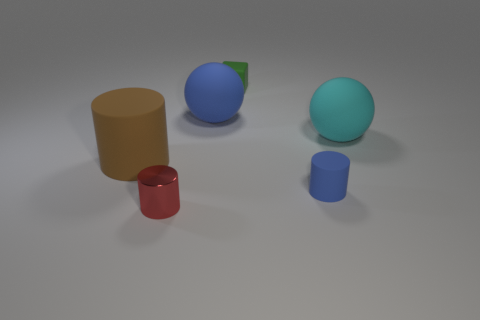Are there any other things that have the same material as the red thing?
Offer a very short reply. No. The cylinder that is left of the block and to the right of the brown rubber object is made of what material?
Make the answer very short. Metal. What color is the small thing that is behind the rubber thing that is to the left of the small object to the left of the tiny green object?
Provide a succinct answer. Green. There is a metallic object that is the same size as the block; what color is it?
Ensure brevity in your answer.  Red. There is a small matte cylinder; is it the same color as the rubber ball to the left of the blue cylinder?
Provide a succinct answer. Yes. There is a small object that is in front of the small blue matte object behind the tiny red metal cylinder; what is its material?
Ensure brevity in your answer.  Metal. How many large objects are in front of the cyan ball and on the right side of the small red object?
Your answer should be compact. 0. There is a object that is in front of the blue matte cylinder; is its shape the same as the blue object on the left side of the small green rubber object?
Provide a succinct answer. No. Are there any blue matte objects in front of the big matte cylinder?
Ensure brevity in your answer.  Yes. What is the color of the big matte object that is the same shape as the metal thing?
Give a very brief answer. Brown. 